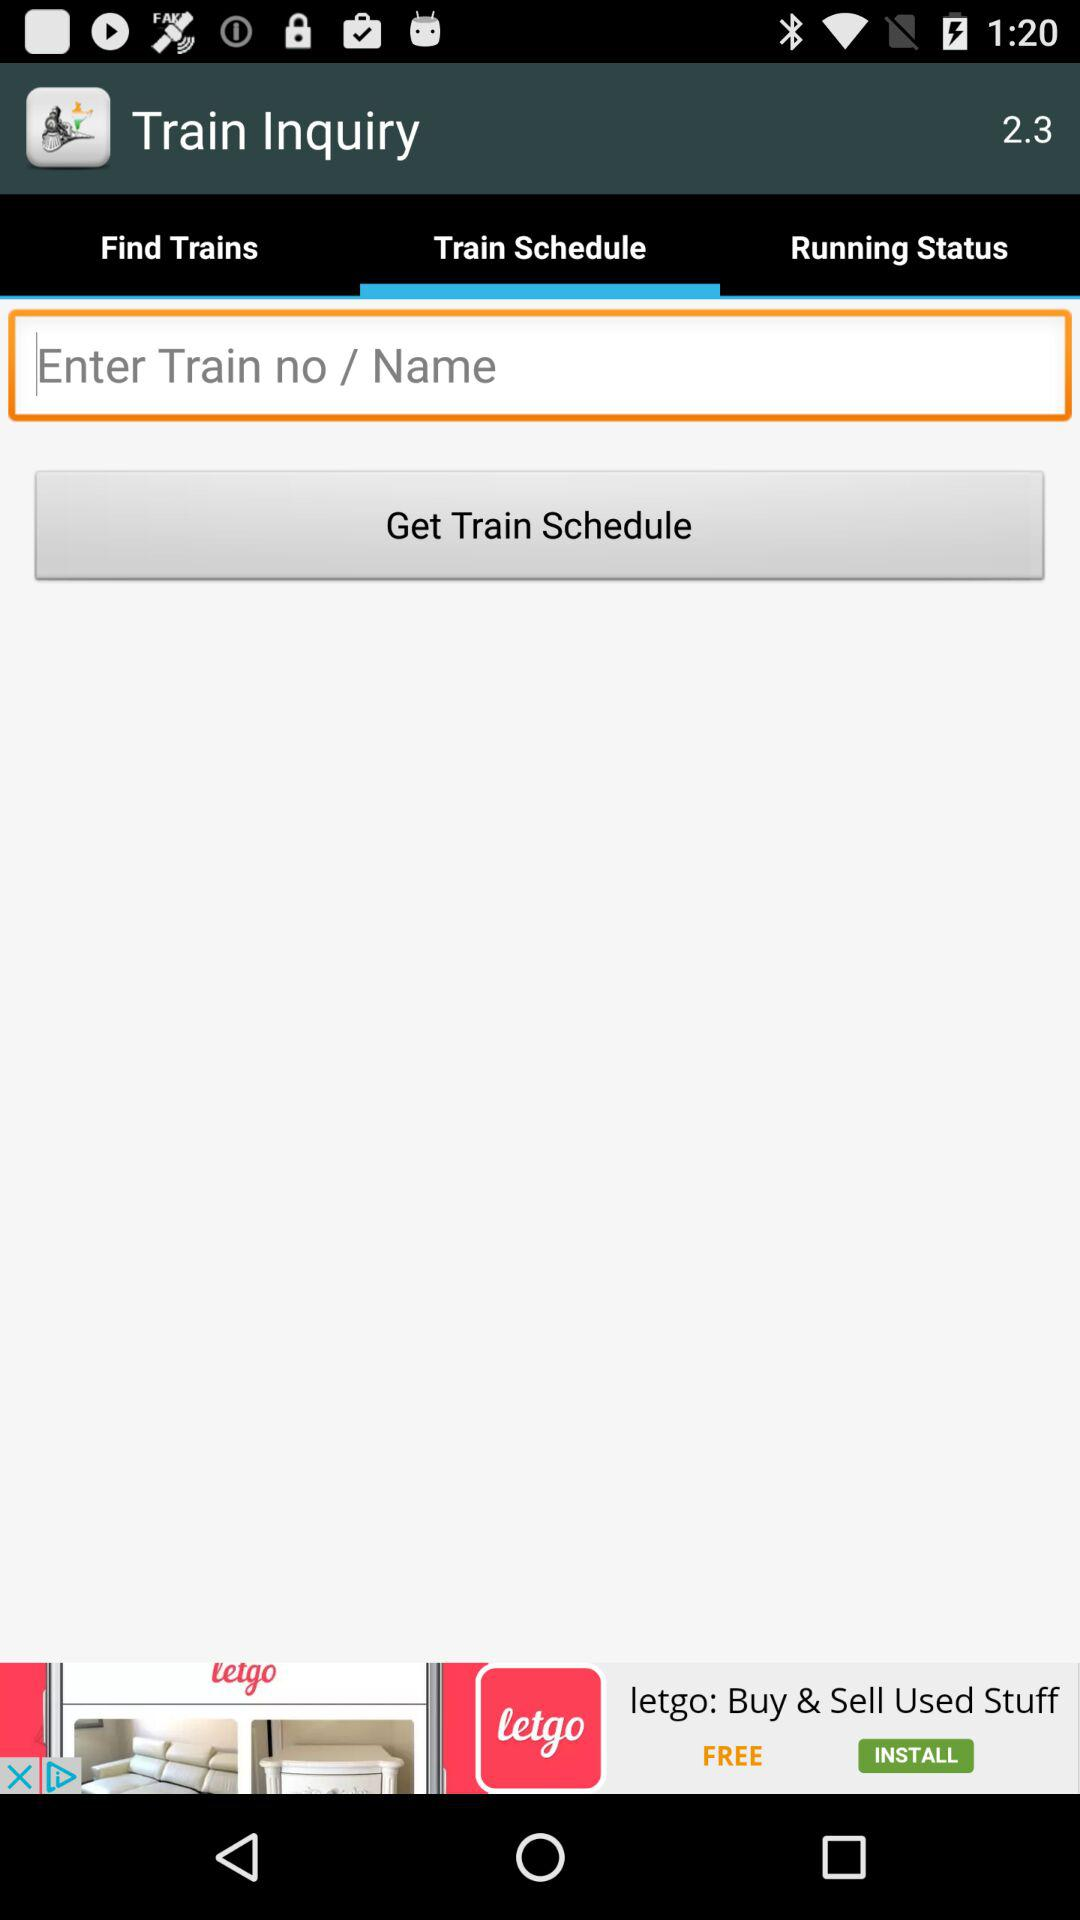What is the name of the application? The name of the application is "Train Inquiry". 